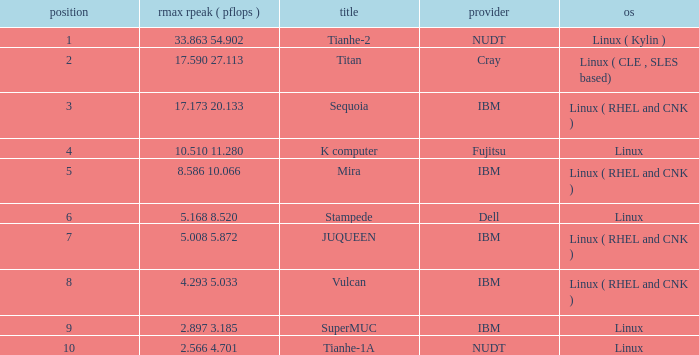Parse the full table. {'header': ['position', 'rmax rpeak ( pflops )', 'title', 'provider', 'os'], 'rows': [['1', '33.863 54.902', 'Tianhe-2', 'NUDT', 'Linux ( Kylin )'], ['2', '17.590 27.113', 'Titan', 'Cray', 'Linux ( CLE , SLES based)'], ['3', '17.173 20.133', 'Sequoia', 'IBM', 'Linux ( RHEL and CNK )'], ['4', '10.510 11.280', 'K computer', 'Fujitsu', 'Linux'], ['5', '8.586 10.066', 'Mira', 'IBM', 'Linux ( RHEL and CNK )'], ['6', '5.168 8.520', 'Stampede', 'Dell', 'Linux'], ['7', '5.008 5.872', 'JUQUEEN', 'IBM', 'Linux ( RHEL and CNK )'], ['8', '4.293 5.033', 'Vulcan', 'IBM', 'Linux ( RHEL and CNK )'], ['9', '2.897 3.185', 'SuperMUC', 'IBM', 'Linux'], ['10', '2.566 4.701', 'Tianhe-1A', 'NUDT', 'Linux']]} What is the name of Rank 5? Mira. 